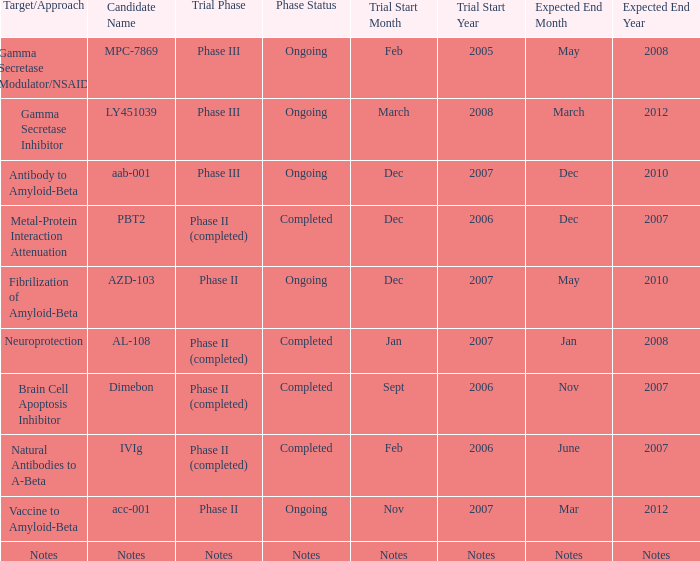What is Trial Start Date, when Candidate Name is Notes? Notes. 